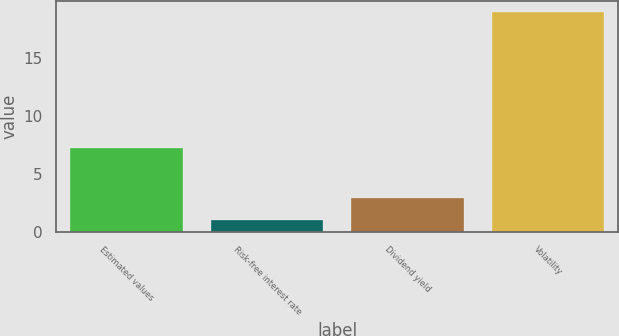Convert chart. <chart><loc_0><loc_0><loc_500><loc_500><bar_chart><fcel>Estimated values<fcel>Risk-free interest rate<fcel>Dividend yield<fcel>Volatility<nl><fcel>7.2<fcel>1<fcel>2.9<fcel>19<nl></chart> 